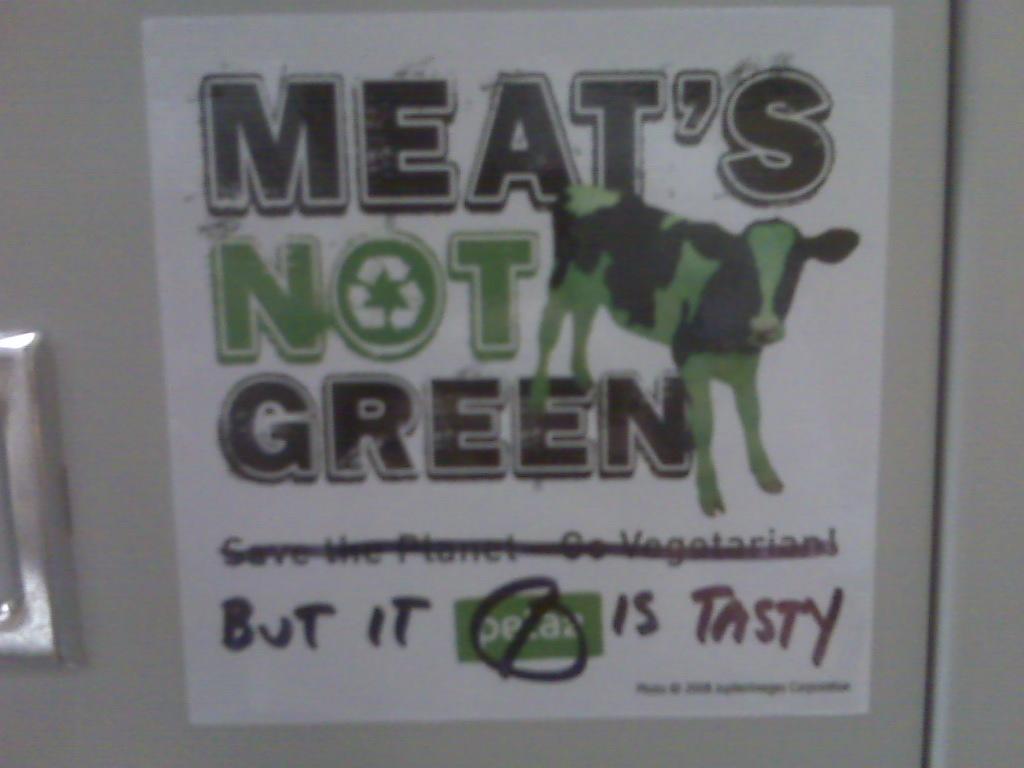Could you give a brief overview of what you see in this image? In the picture we can see a poster on which we can see some text and a picture of a cow. 